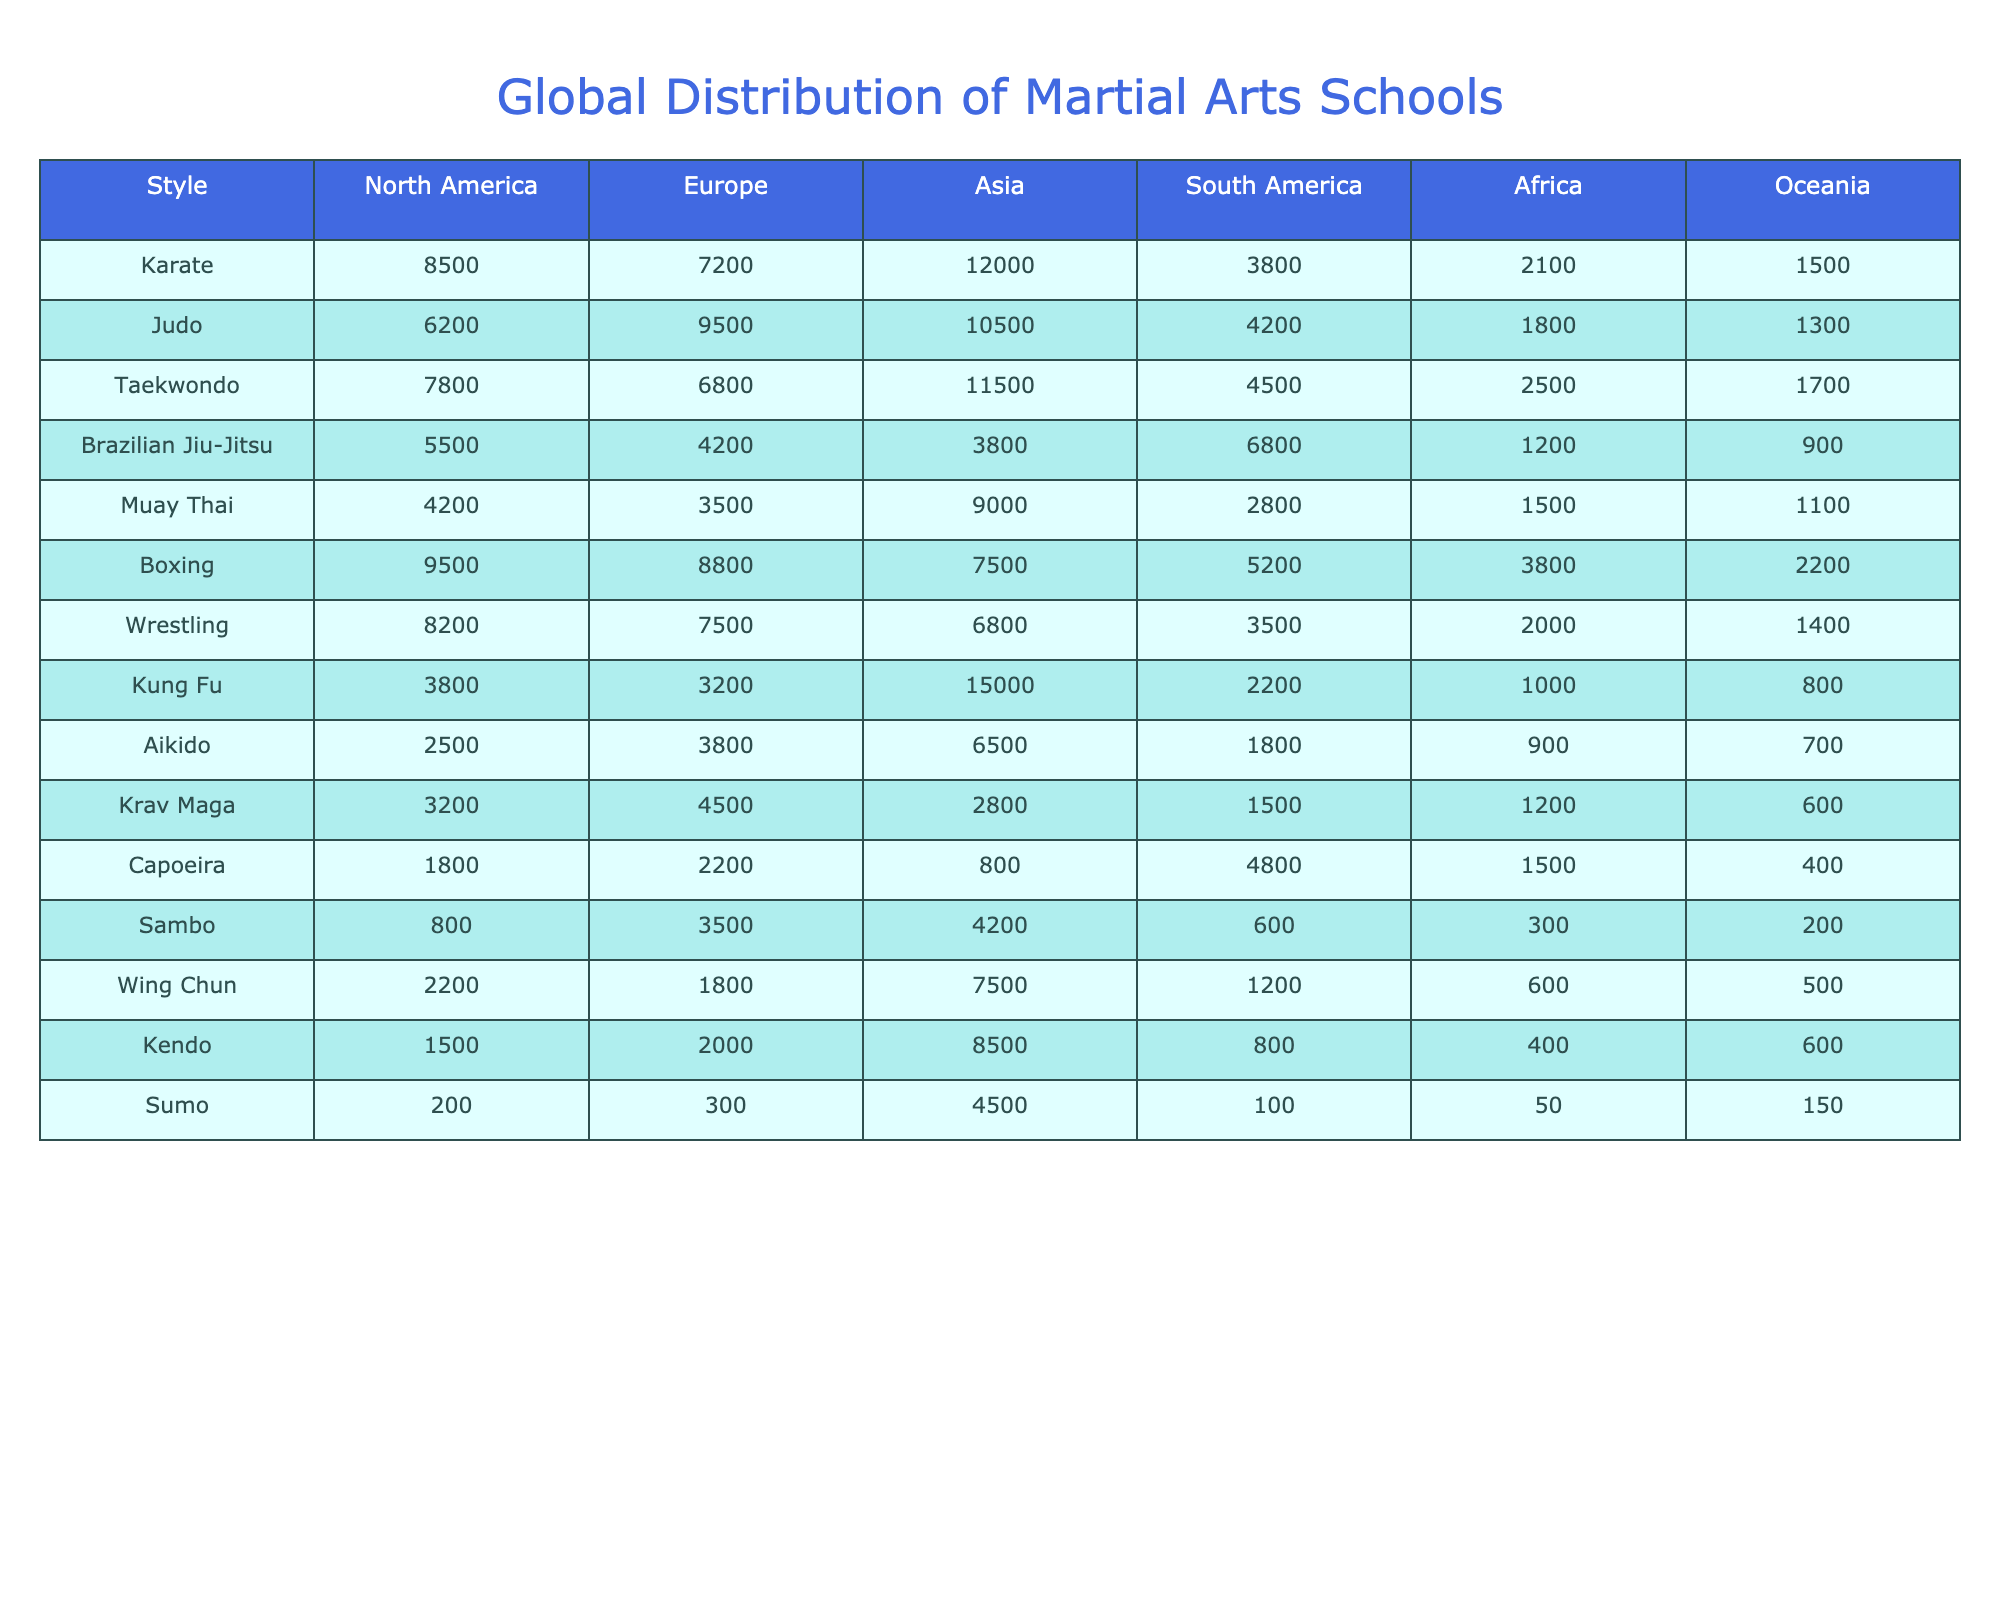What is the total number of Karate schools in North America? The table shows that there are 8500 Karate schools in North America.
Answer: 8500 Which martial art has the highest number of schools in Asia? According to the table, Kung Fu has 15000 schools in Asia, the highest among the listed styles.
Answer: Kung Fu Is there a style of martial arts with fewer than 300 schools in any region? The data indicates that Sumo has only 200 schools in Africa, confirming that there is a style with fewer than 300 schools in a region.
Answer: Yes What is the total number of Judo schools across all regions? To find the total for Judo, we add the number of schools in all regions: 6200 + 9500 + 10500 + 4200 + 1800 + 1300 = 30000.
Answer: 30000 What is the difference in the number of Taekwondo schools between North America and South America? The number of Taekwondo schools in North America is 7800, and in South America, it is 4500. The difference is 7800 - 4500 = 3300.
Answer: 3300 Which region has the most Muay Thai schools? From the table, Asia has the highest number of Muay Thai schools with 9000.
Answer: Asia If we combine the school counts for Boxing in North America and Europe, what is the total? In North America, there are 9500 Boxing schools, and in Europe, there are 8800. Adding them gives 9500 + 8800 = 18300.
Answer: 18300 Are there more schools for Brazilian Jiu-Jitsu in South America than in Asia? The table indicates that there are 6800 schools in South America and 3800 schools in Asia, so there are more in South America.
Answer: Yes What is the average number of Karate schools across all regions? To find the average, we sum the Karate schools: 8500 + 7200 + 12000 + 3800 + 2100 + 1500 = 29900, and divide by the number of regions (6), resulting in 29900 / 6 ≈ 4983.33.
Answer: 4983.33 Which martial art has the least presence in terms of total schools across all regions? Analyzing the totals, Sumo has only 600 schools total when adding all regions, which is the lowest number.
Answer: Sumo 